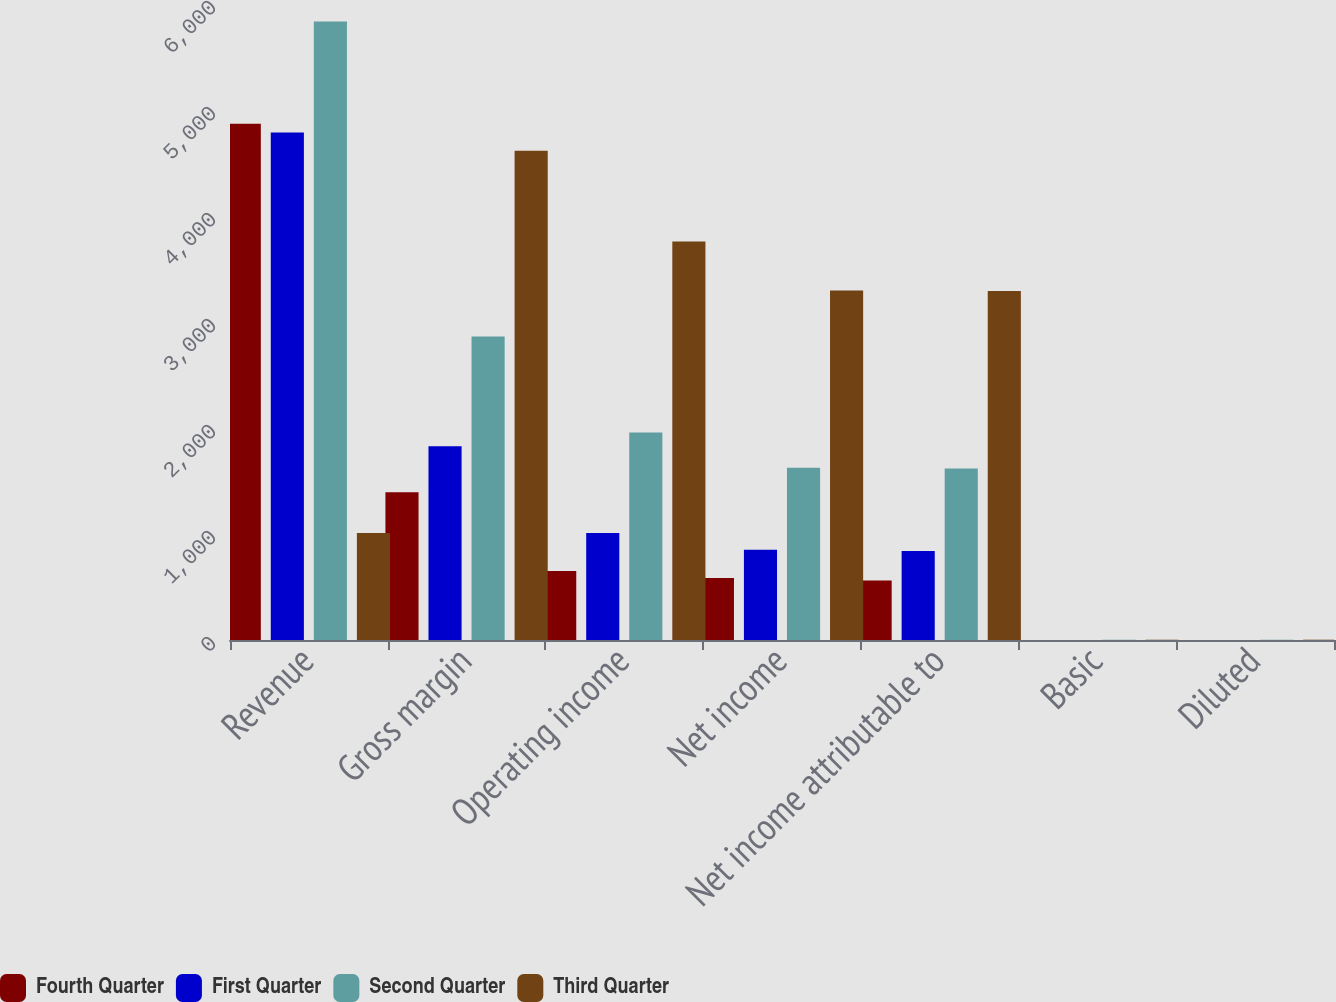Convert chart. <chart><loc_0><loc_0><loc_500><loc_500><stacked_bar_chart><ecel><fcel>Revenue<fcel>Gross margin<fcel>Operating income<fcel>Net income<fcel>Net income attributable to<fcel>Basic<fcel>Diluted<nl><fcel>Fourth Quarter<fcel>4870<fcel>1395<fcel>650<fcel>586<fcel>561<fcel>0.51<fcel>0.49<nl><fcel>First Quarter<fcel>4788<fcel>1828<fcel>1010<fcel>851<fcel>840<fcel>0.76<fcel>0.74<nl><fcel>Second Quarter<fcel>5835<fcel>2864<fcel>1957<fcel>1625<fcel>1619<fcel>1.45<fcel>1.42<nl><fcel>Third Quarter<fcel>1010<fcel>4615<fcel>3759<fcel>3296<fcel>3293<fcel>2.91<fcel>2.81<nl></chart> 